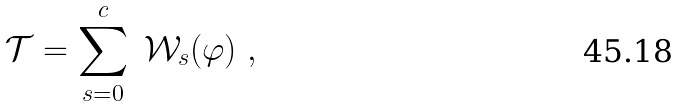Convert formula to latex. <formula><loc_0><loc_0><loc_500><loc_500>\mathcal { T } = \sum _ { s = 0 } ^ { c } \ \mathcal { W } _ { s } ( \varphi ) \ ,</formula> 